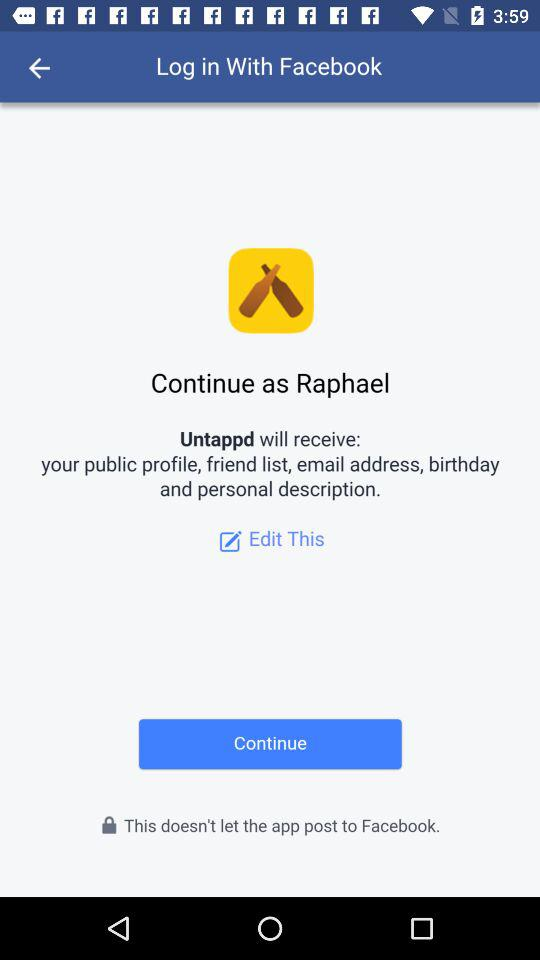What is the name of the user? The name of the user is Raphael. 